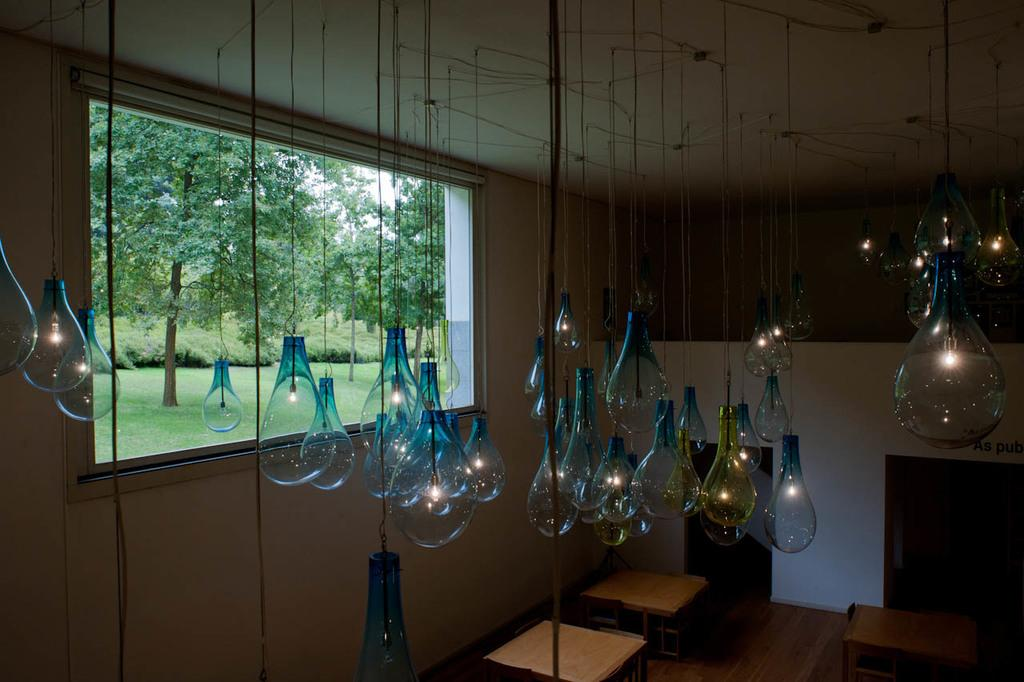What objects can be seen in the foreground of the image? There are tables in the foreground of the image. What architectural feature is present in the image? There is a window in the image. What type of vegetation is visible in the image? Trees and grass are visible in the image. What part of the natural environment is visible in the image? The sky is visible in the image. What type of lighting is present in the image? Lamps are hanged on the wall in the image. Can you describe the setting where the image was taken? The image may have been taken in a room, as indicated by the presence of tables and lamps. What type of health issues are being discussed in the image? There is no indication of any health issues being discussed in the image. Can you see a ball being played with in the image? There is no ball present in the image. 